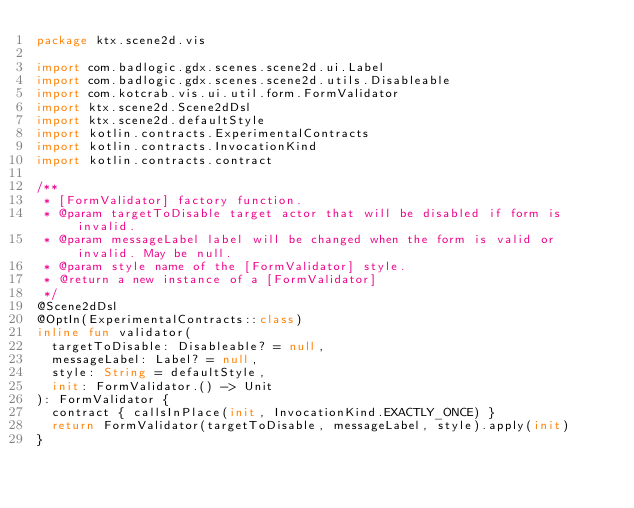<code> <loc_0><loc_0><loc_500><loc_500><_Kotlin_>package ktx.scene2d.vis

import com.badlogic.gdx.scenes.scene2d.ui.Label
import com.badlogic.gdx.scenes.scene2d.utils.Disableable
import com.kotcrab.vis.ui.util.form.FormValidator
import ktx.scene2d.Scene2dDsl
import ktx.scene2d.defaultStyle
import kotlin.contracts.ExperimentalContracts
import kotlin.contracts.InvocationKind
import kotlin.contracts.contract

/**
 * [FormValidator] factory function.
 * @param targetToDisable target actor that will be disabled if form is invalid.
 * @param messageLabel label will be changed when the form is valid or invalid. May be null.
 * @param style name of the [FormValidator] style.
 * @return a new instance of a [FormValidator]
 */
@Scene2dDsl
@OptIn(ExperimentalContracts::class)
inline fun validator(
  targetToDisable: Disableable? = null,
  messageLabel: Label? = null,
  style: String = defaultStyle,
  init: FormValidator.() -> Unit
): FormValidator {
  contract { callsInPlace(init, InvocationKind.EXACTLY_ONCE) }
  return FormValidator(targetToDisable, messageLabel, style).apply(init)
}
</code> 